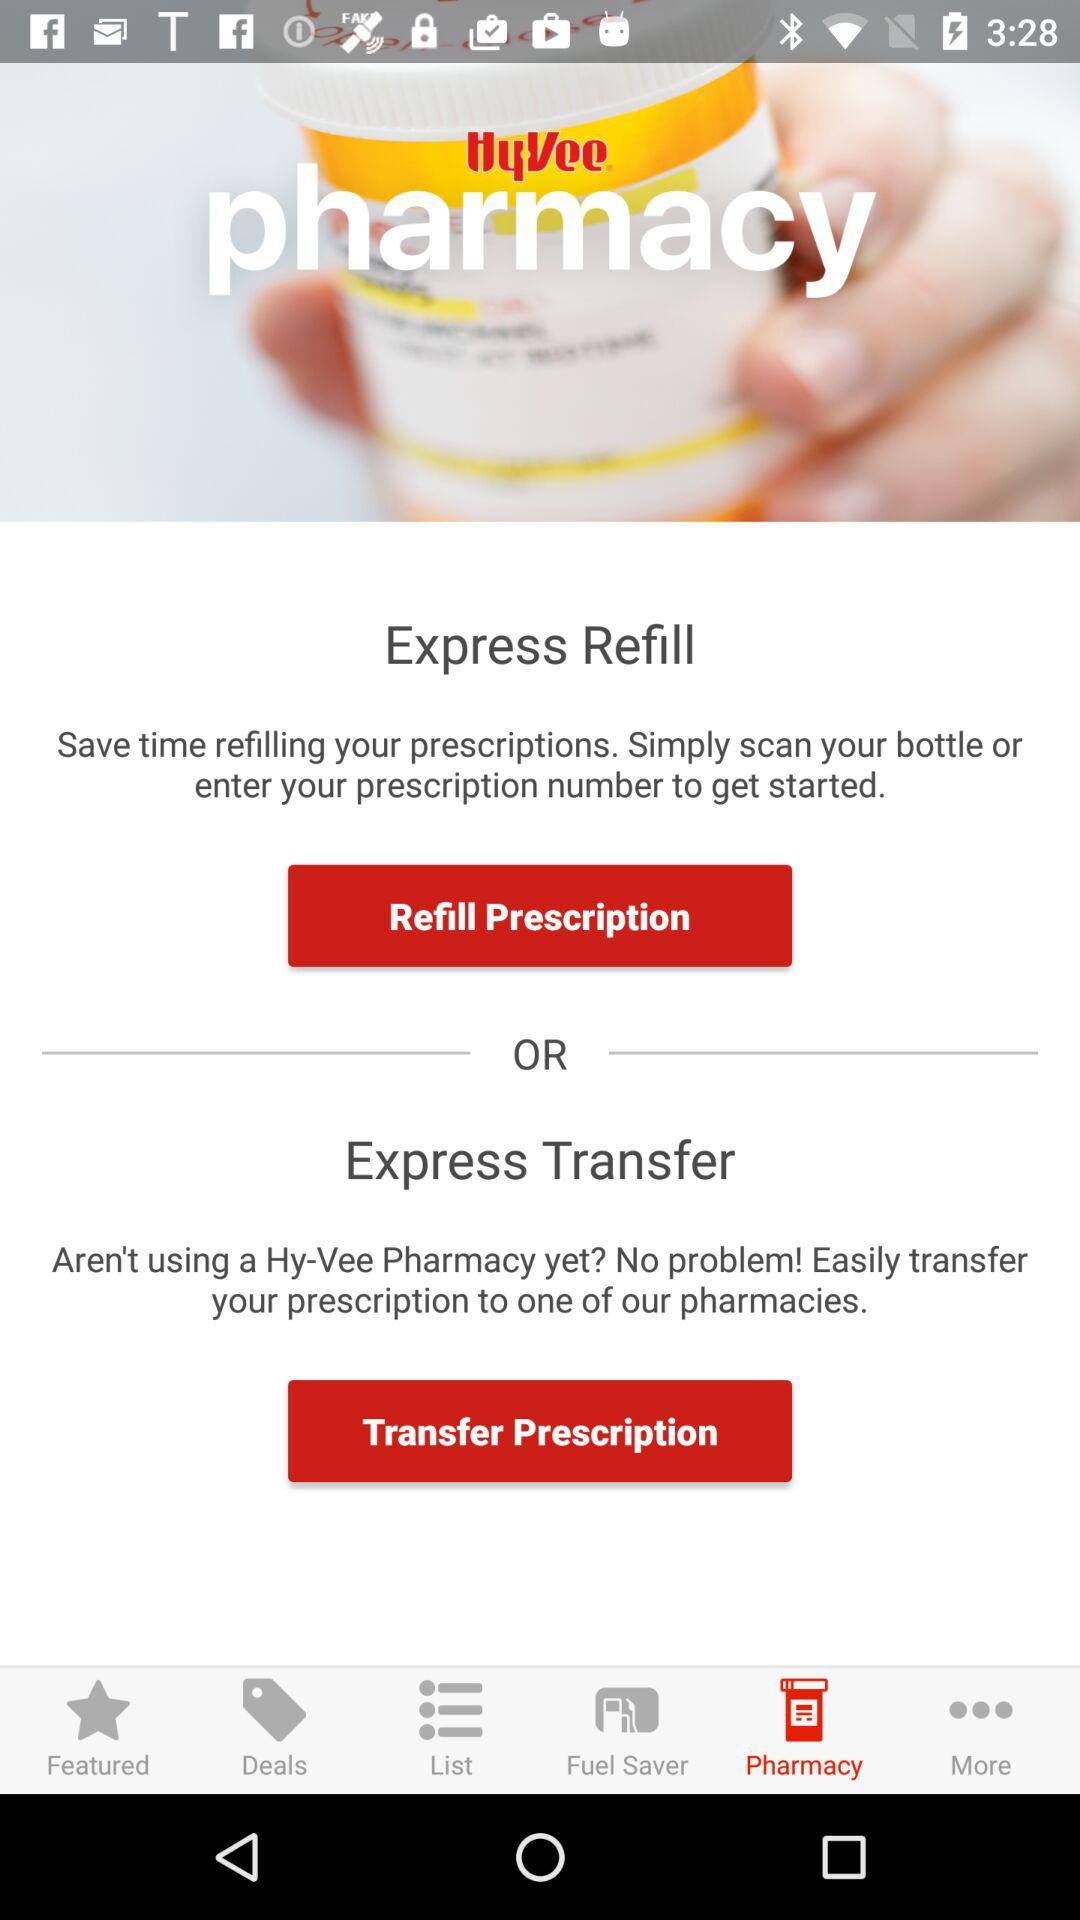Which tab is selected? The selected tab is "Pharmacy". 